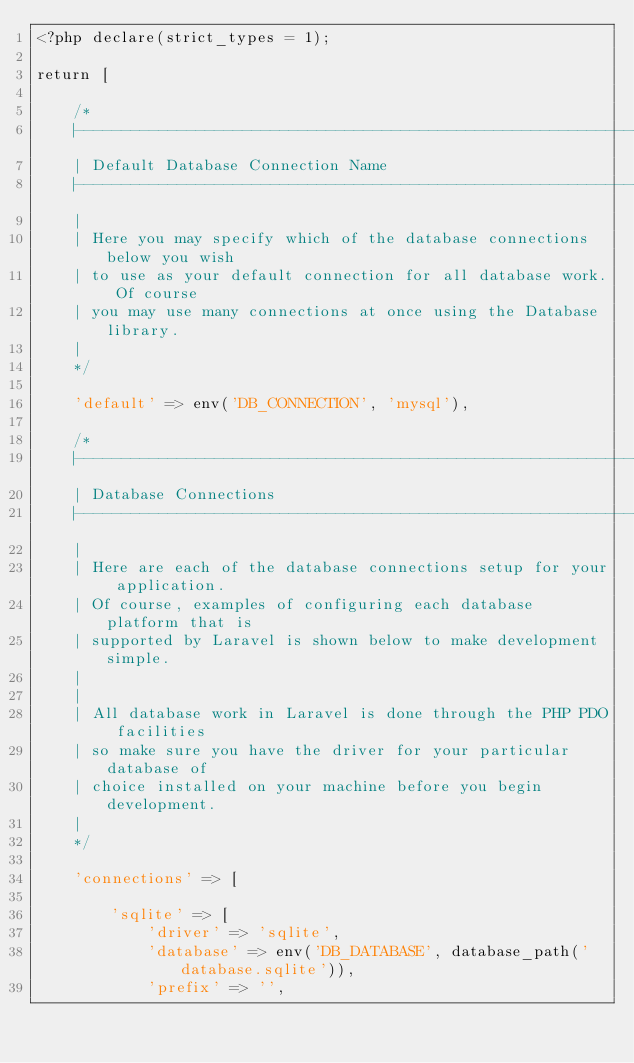Convert code to text. <code><loc_0><loc_0><loc_500><loc_500><_PHP_><?php declare(strict_types = 1);

return [

    /*
    |--------------------------------------------------------------------------
    | Default Database Connection Name
    |--------------------------------------------------------------------------
    |
    | Here you may specify which of the database connections below you wish
    | to use as your default connection for all database work. Of course
    | you may use many connections at once using the Database library.
    |
    */

    'default' => env('DB_CONNECTION', 'mysql'),

    /*
    |--------------------------------------------------------------------------
    | Database Connections
    |--------------------------------------------------------------------------
    |
    | Here are each of the database connections setup for your application.
    | Of course, examples of configuring each database platform that is
    | supported by Laravel is shown below to make development simple.
    |
    |
    | All database work in Laravel is done through the PHP PDO facilities
    | so make sure you have the driver for your particular database of
    | choice installed on your machine before you begin development.
    |
    */

    'connections' => [

        'sqlite' => [
            'driver' => 'sqlite',
            'database' => env('DB_DATABASE', database_path('database.sqlite')),
            'prefix' => '',</code> 